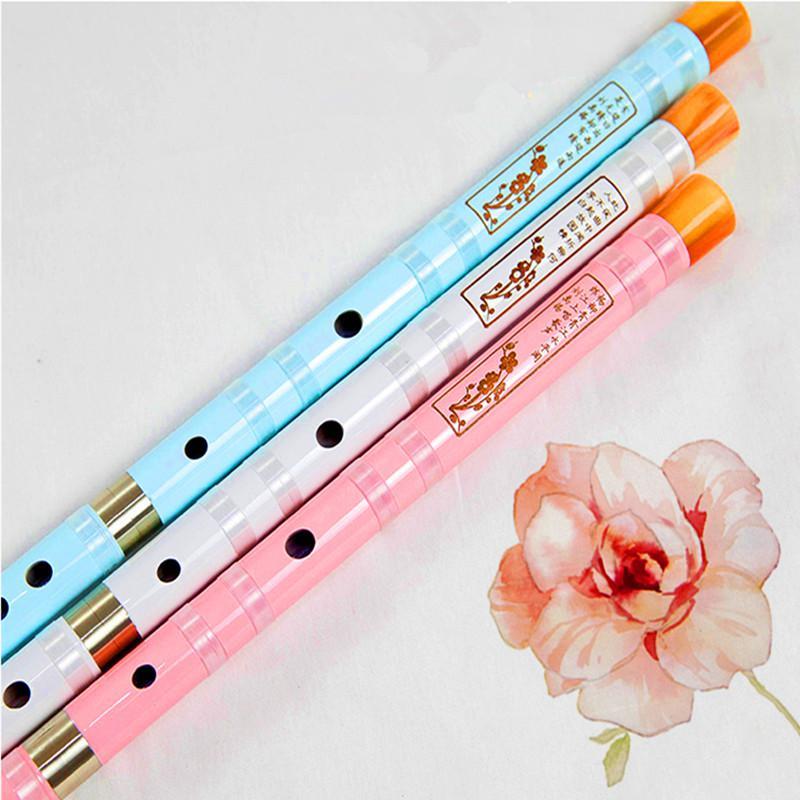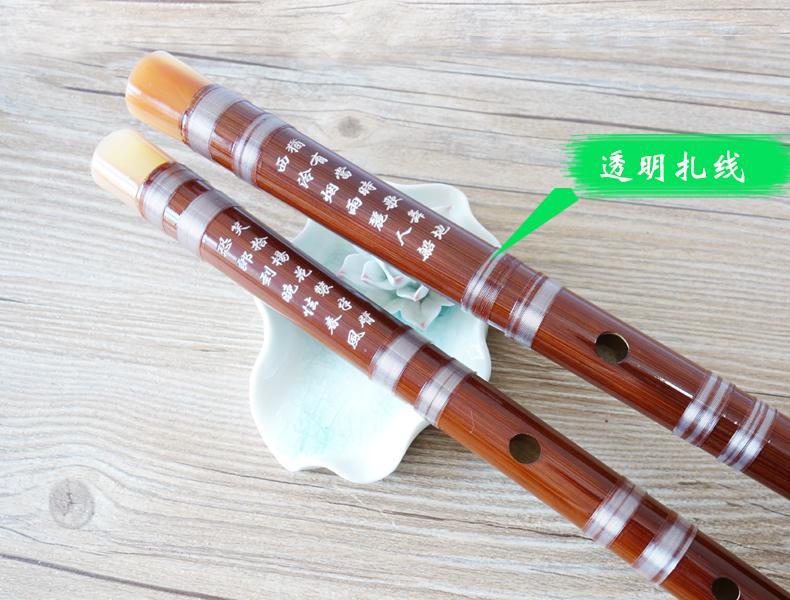The first image is the image on the left, the second image is the image on the right. Examine the images to the left and right. Is the description "The left image has more flutes than the right image." accurate? Answer yes or no. Yes. The first image is the image on the left, the second image is the image on the right. Evaluate the accuracy of this statement regarding the images: "There are exactly five flutes.". Is it true? Answer yes or no. Yes. 